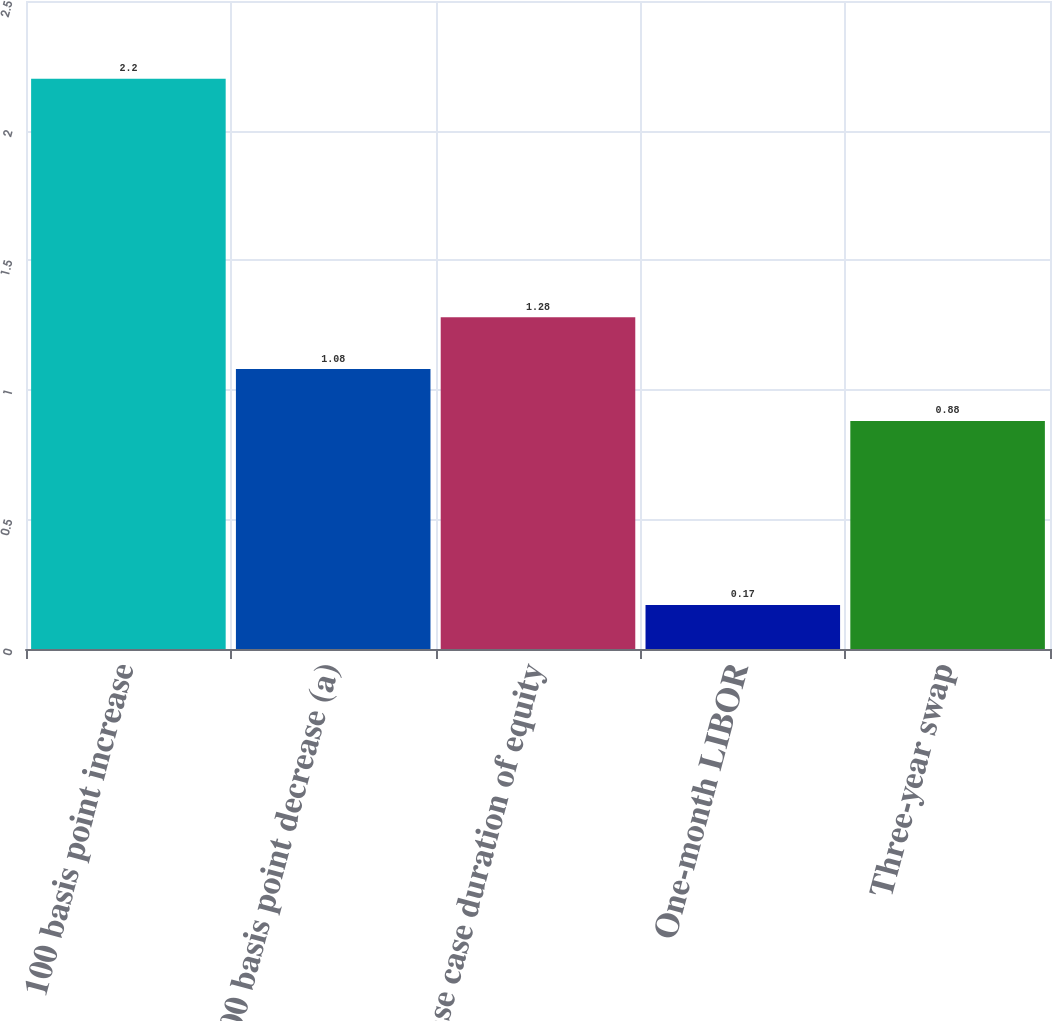<chart> <loc_0><loc_0><loc_500><loc_500><bar_chart><fcel>100 basis point increase<fcel>100 basis point decrease (a)<fcel>Base case duration of equity<fcel>One-month LIBOR<fcel>Three-year swap<nl><fcel>2.2<fcel>1.08<fcel>1.28<fcel>0.17<fcel>0.88<nl></chart> 